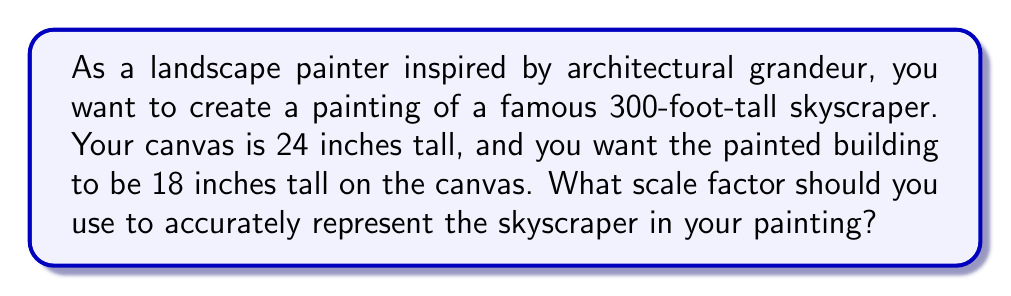Solve this math problem. To solve this problem, we need to determine the ratio between the size of the object in the painting and its actual size. This ratio is our scale factor.

Let's approach this step-by-step:

1) First, we need to convert all measurements to the same unit. Let's use inches:
   
   Actual height of skyscraper = 300 feet = 300 × 12 = 3600 inches
   Height of building in painting = 18 inches

2) The scale factor is the ratio of the painted size to the actual size:

   $$ \text{Scale factor} = \frac{\text{Size in painting}}{\text{Actual size}} $$

3) Substituting our values:

   $$ \text{Scale factor} = \frac{18 \text{ inches}}{3600 \text{ inches}} $$

4) Simplify the fraction:

   $$ \text{Scale factor} = \frac{1}{200} = 0.005 $$

This means that each inch in the painting represents 200 inches in reality, or 1/200th of the actual size.

To verify:
- If we multiply the actual height (3600 inches) by our scale factor (0.005), we get 18 inches, which is the desired height in the painting.

Note: In terms of the canvas size, the 18-inch representation fits well within the 24-inch tall canvas, leaving room for other elements in the painting.
Answer: The scale factor needed is $\frac{1}{200}$ or 0.005. 